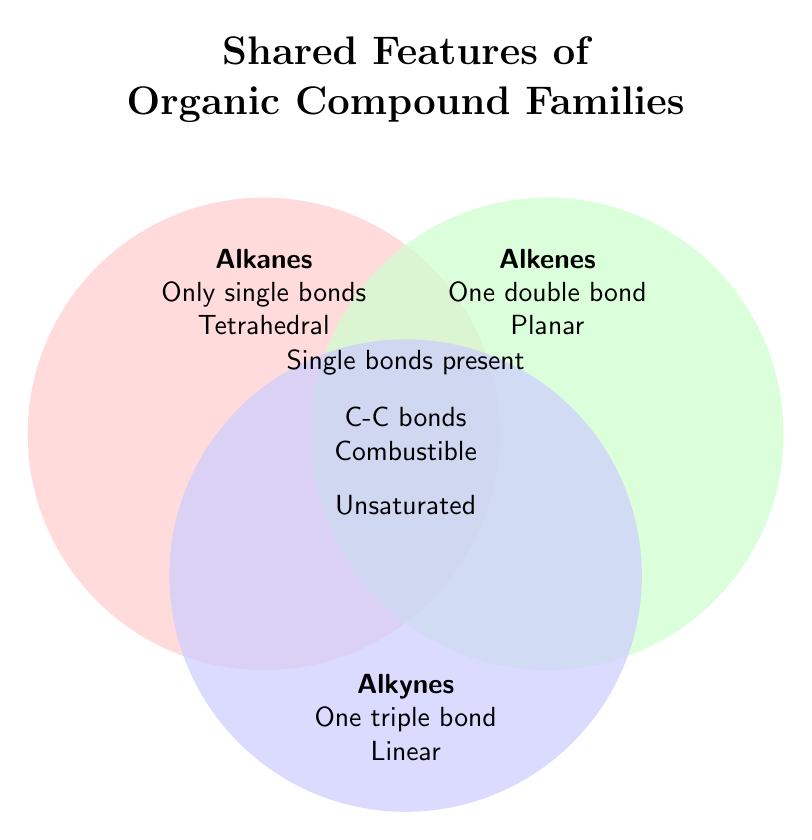What are the unique features of Alkanes? Look at the part of the diagram labeled "Alkanes". It lists two unique features: "Only single bonds" and "Tetrahedral geometry".
Answer: Only single bonds; Tetrahedral geometry Which compound family has a feature of having "One triple bond"? Look at the diagram section labeled "Alkynes". It lists "One triple bond" as a feature.
Answer: Alkynes What feature is shared by Alkanes, Alkenes, and Alkynes? Locate the central overlapping area of the Venn Diagram where all three sets intersect. This area lists two common features: "Carbon-carbon bonds" and "Combustible".
Answer: Carbon-carbon bonds; Combustible Do Alkanes and Alkenes share any features? If so, what are they? Look at the intersecting area between Alkanes and Alkenes. It lists "Single bonds present" as a shared feature.
Answer: Single bonds present Which feature is listed as unique to Alkenes? Find the section labeled "Alkenes". It specifies "One double bond" and "Planar geometry" as unique features.
Answer: One double bond; Planar geometry Which compound families are described as "Unsaturated"? Check the overlapping section between Alkenes and Alkynes. This area lists "Unsaturated" as a common feature between these two families.
Answer: Alkenes; Alkynes How many features are unique to Alkynes? What are they? Locate the section labeled "Alkynes". It lists two unique features: "One triple bond" and "Linear geometry".
Answer: Two; One triple bond; Linear geometry What geometric shape is associated with Alkanes? Look at the section labeled "Alkanes". It mentions "Tetrahedral geometry" as a feature.
Answer: Tetrahedral Which families have features related to geometric shapes, and what are these shapes respectively? Inspect the sections for each compound family. Alkanes have "Tetrahedral geometry", Alkenes have "Planar geometry", and Alkynes have "Linear geometry".
Answer: Alkanes: Tetrahedral; Alkenes: Planar; Alkynes: Linear How many features do the Alkanes have in total, including both unique and shared ones? Count the features listed in the section labeled "Alkanes" and add the shared features from overlaps. Alkanes have two unique features ("Only single bonds", "Tetrahedral geometry") and two shared features in two different areas ("Single bonds present" with Alkenes, "Carbon-carbon bonds" and "Combustible" with all three). That totals 4 features.
Answer: Four 